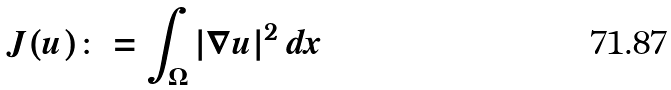Convert formula to latex. <formula><loc_0><loc_0><loc_500><loc_500>J ( u ) \colon = \int _ { \Omega } | \nabla u | ^ { 2 } \, d x</formula> 